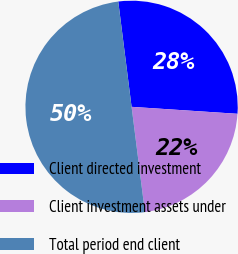Convert chart. <chart><loc_0><loc_0><loc_500><loc_500><pie_chart><fcel>Client directed investment<fcel>Client investment assets under<fcel>Total period end client<nl><fcel>28.05%<fcel>21.95%<fcel>50.0%<nl></chart> 